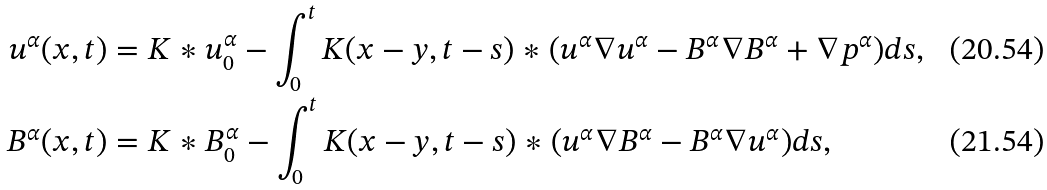<formula> <loc_0><loc_0><loc_500><loc_500>u ^ { \alpha } ( x , t ) & = K * u _ { 0 } ^ { \alpha } - \int ^ { t } _ { 0 } K ( x - y , t - s ) * ( u ^ { \alpha } \nabla u ^ { \alpha } - B ^ { \alpha } \nabla B ^ { \alpha } + \nabla p ^ { \alpha } ) d s , \\ B ^ { \alpha } ( x , t ) & = K * B _ { 0 } ^ { \alpha } - \int ^ { t } _ { 0 } K ( x - y , t - s ) * ( u ^ { \alpha } \nabla B ^ { \alpha } - B ^ { \alpha } \nabla u ^ { \alpha } ) d s ,</formula> 